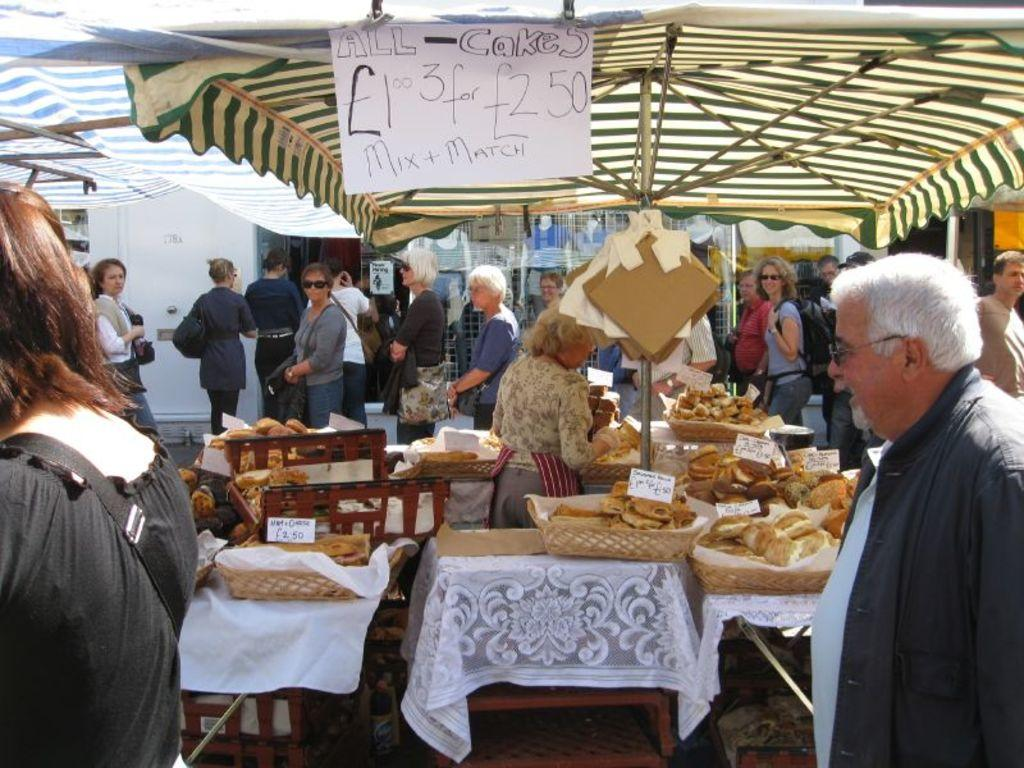What is the main subject of the image? The main subject of the image is a crowd. What are the people in the crowd doing? The crowd is standing around food stalls. Where are the food stalls located? The food stalls are under a tent. What can be seen on a bench in the image? There are cakes on a bench in the image. Is there any information about the cost of the food in the image? Yes, there is a label showing the price of food in the image. What type of rhythm does the scarecrow have in the image? There is no scarecrow present in the image, so it is not possible to determine its rhythm. 